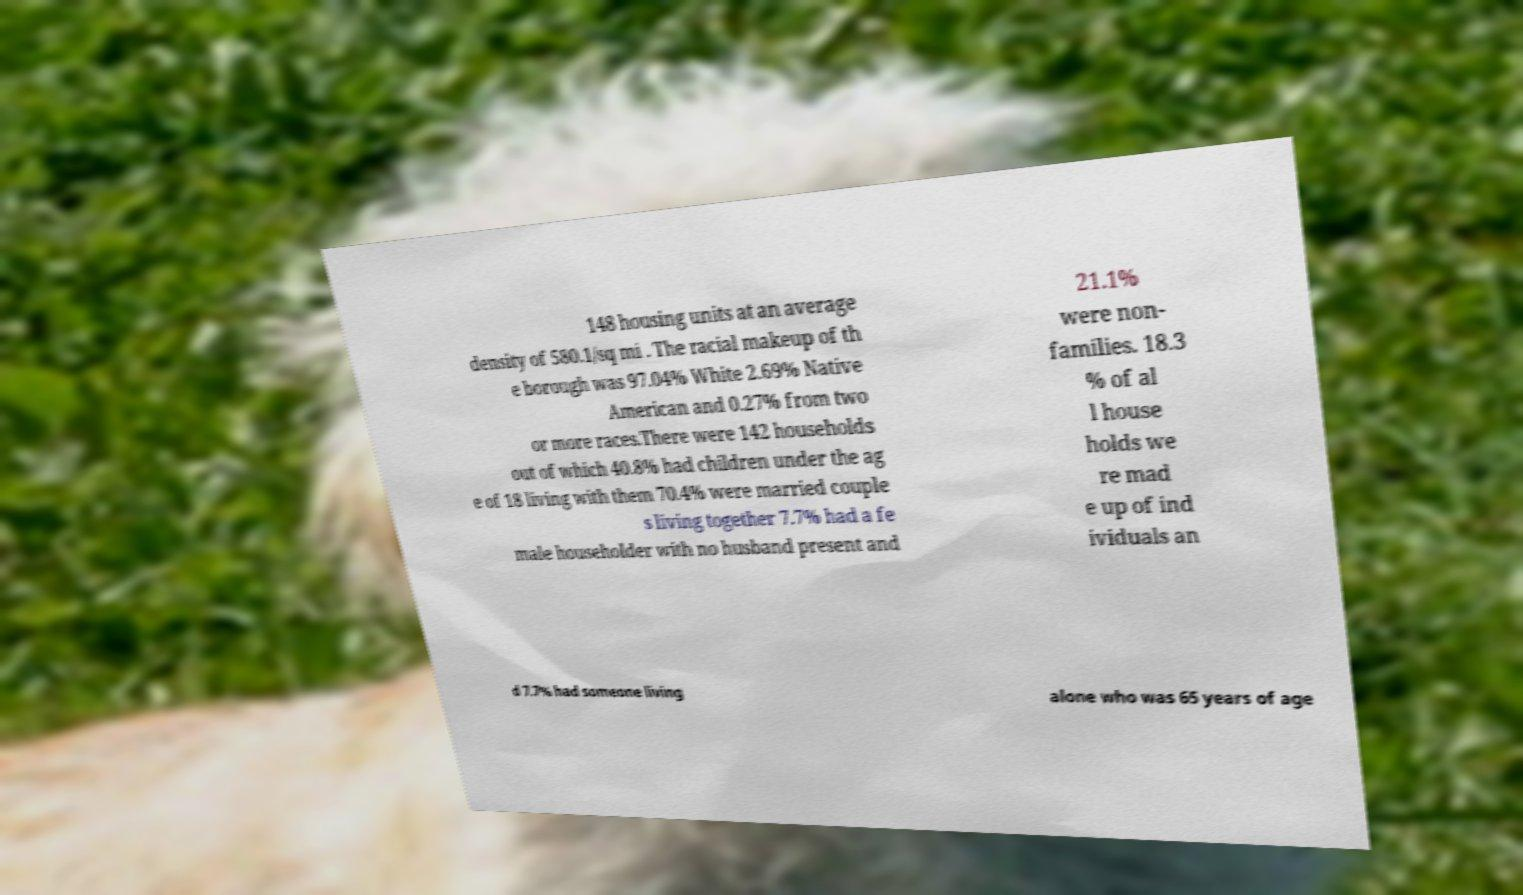Can you accurately transcribe the text from the provided image for me? 148 housing units at an average density of 580.1/sq mi . The racial makeup of th e borough was 97.04% White 2.69% Native American and 0.27% from two or more races.There were 142 households out of which 40.8% had children under the ag e of 18 living with them 70.4% were married couple s living together 7.7% had a fe male householder with no husband present and 21.1% were non- families. 18.3 % of al l house holds we re mad e up of ind ividuals an d 7.7% had someone living alone who was 65 years of age 